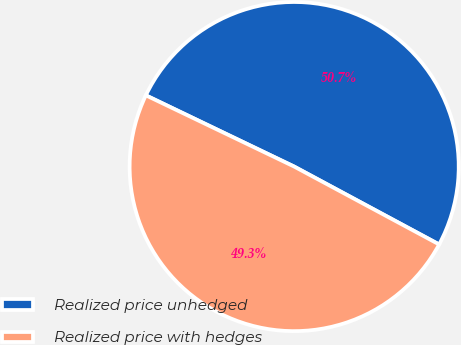Convert chart. <chart><loc_0><loc_0><loc_500><loc_500><pie_chart><fcel>Realized price unhedged<fcel>Realized price with hedges<nl><fcel>50.72%<fcel>49.28%<nl></chart> 